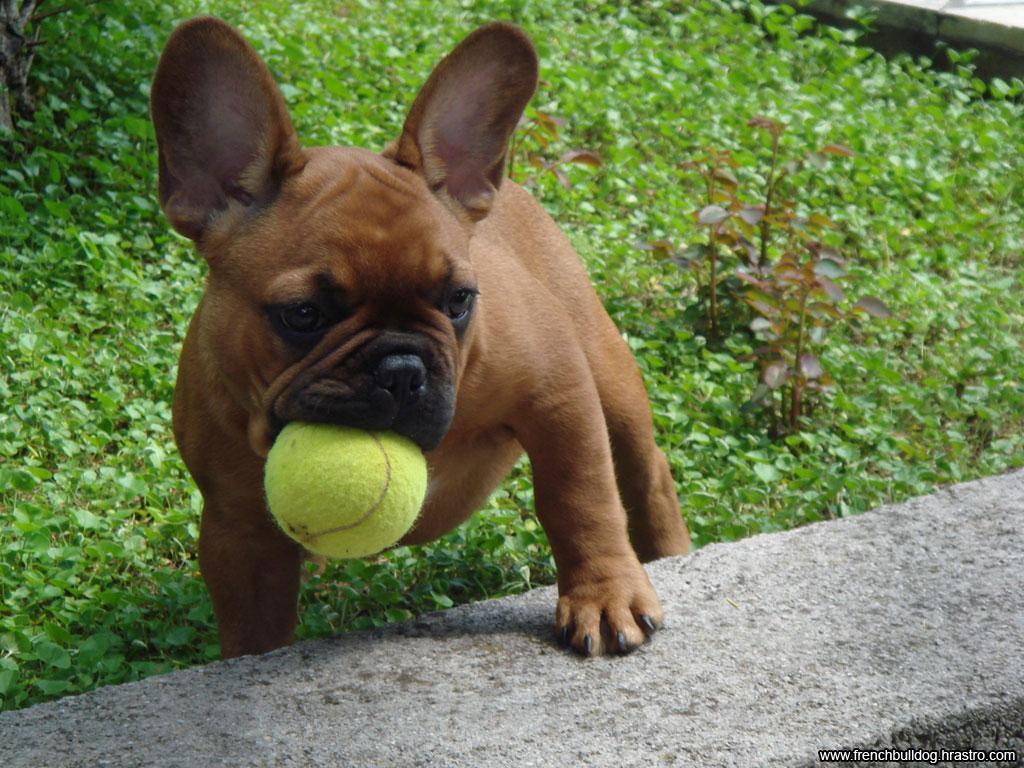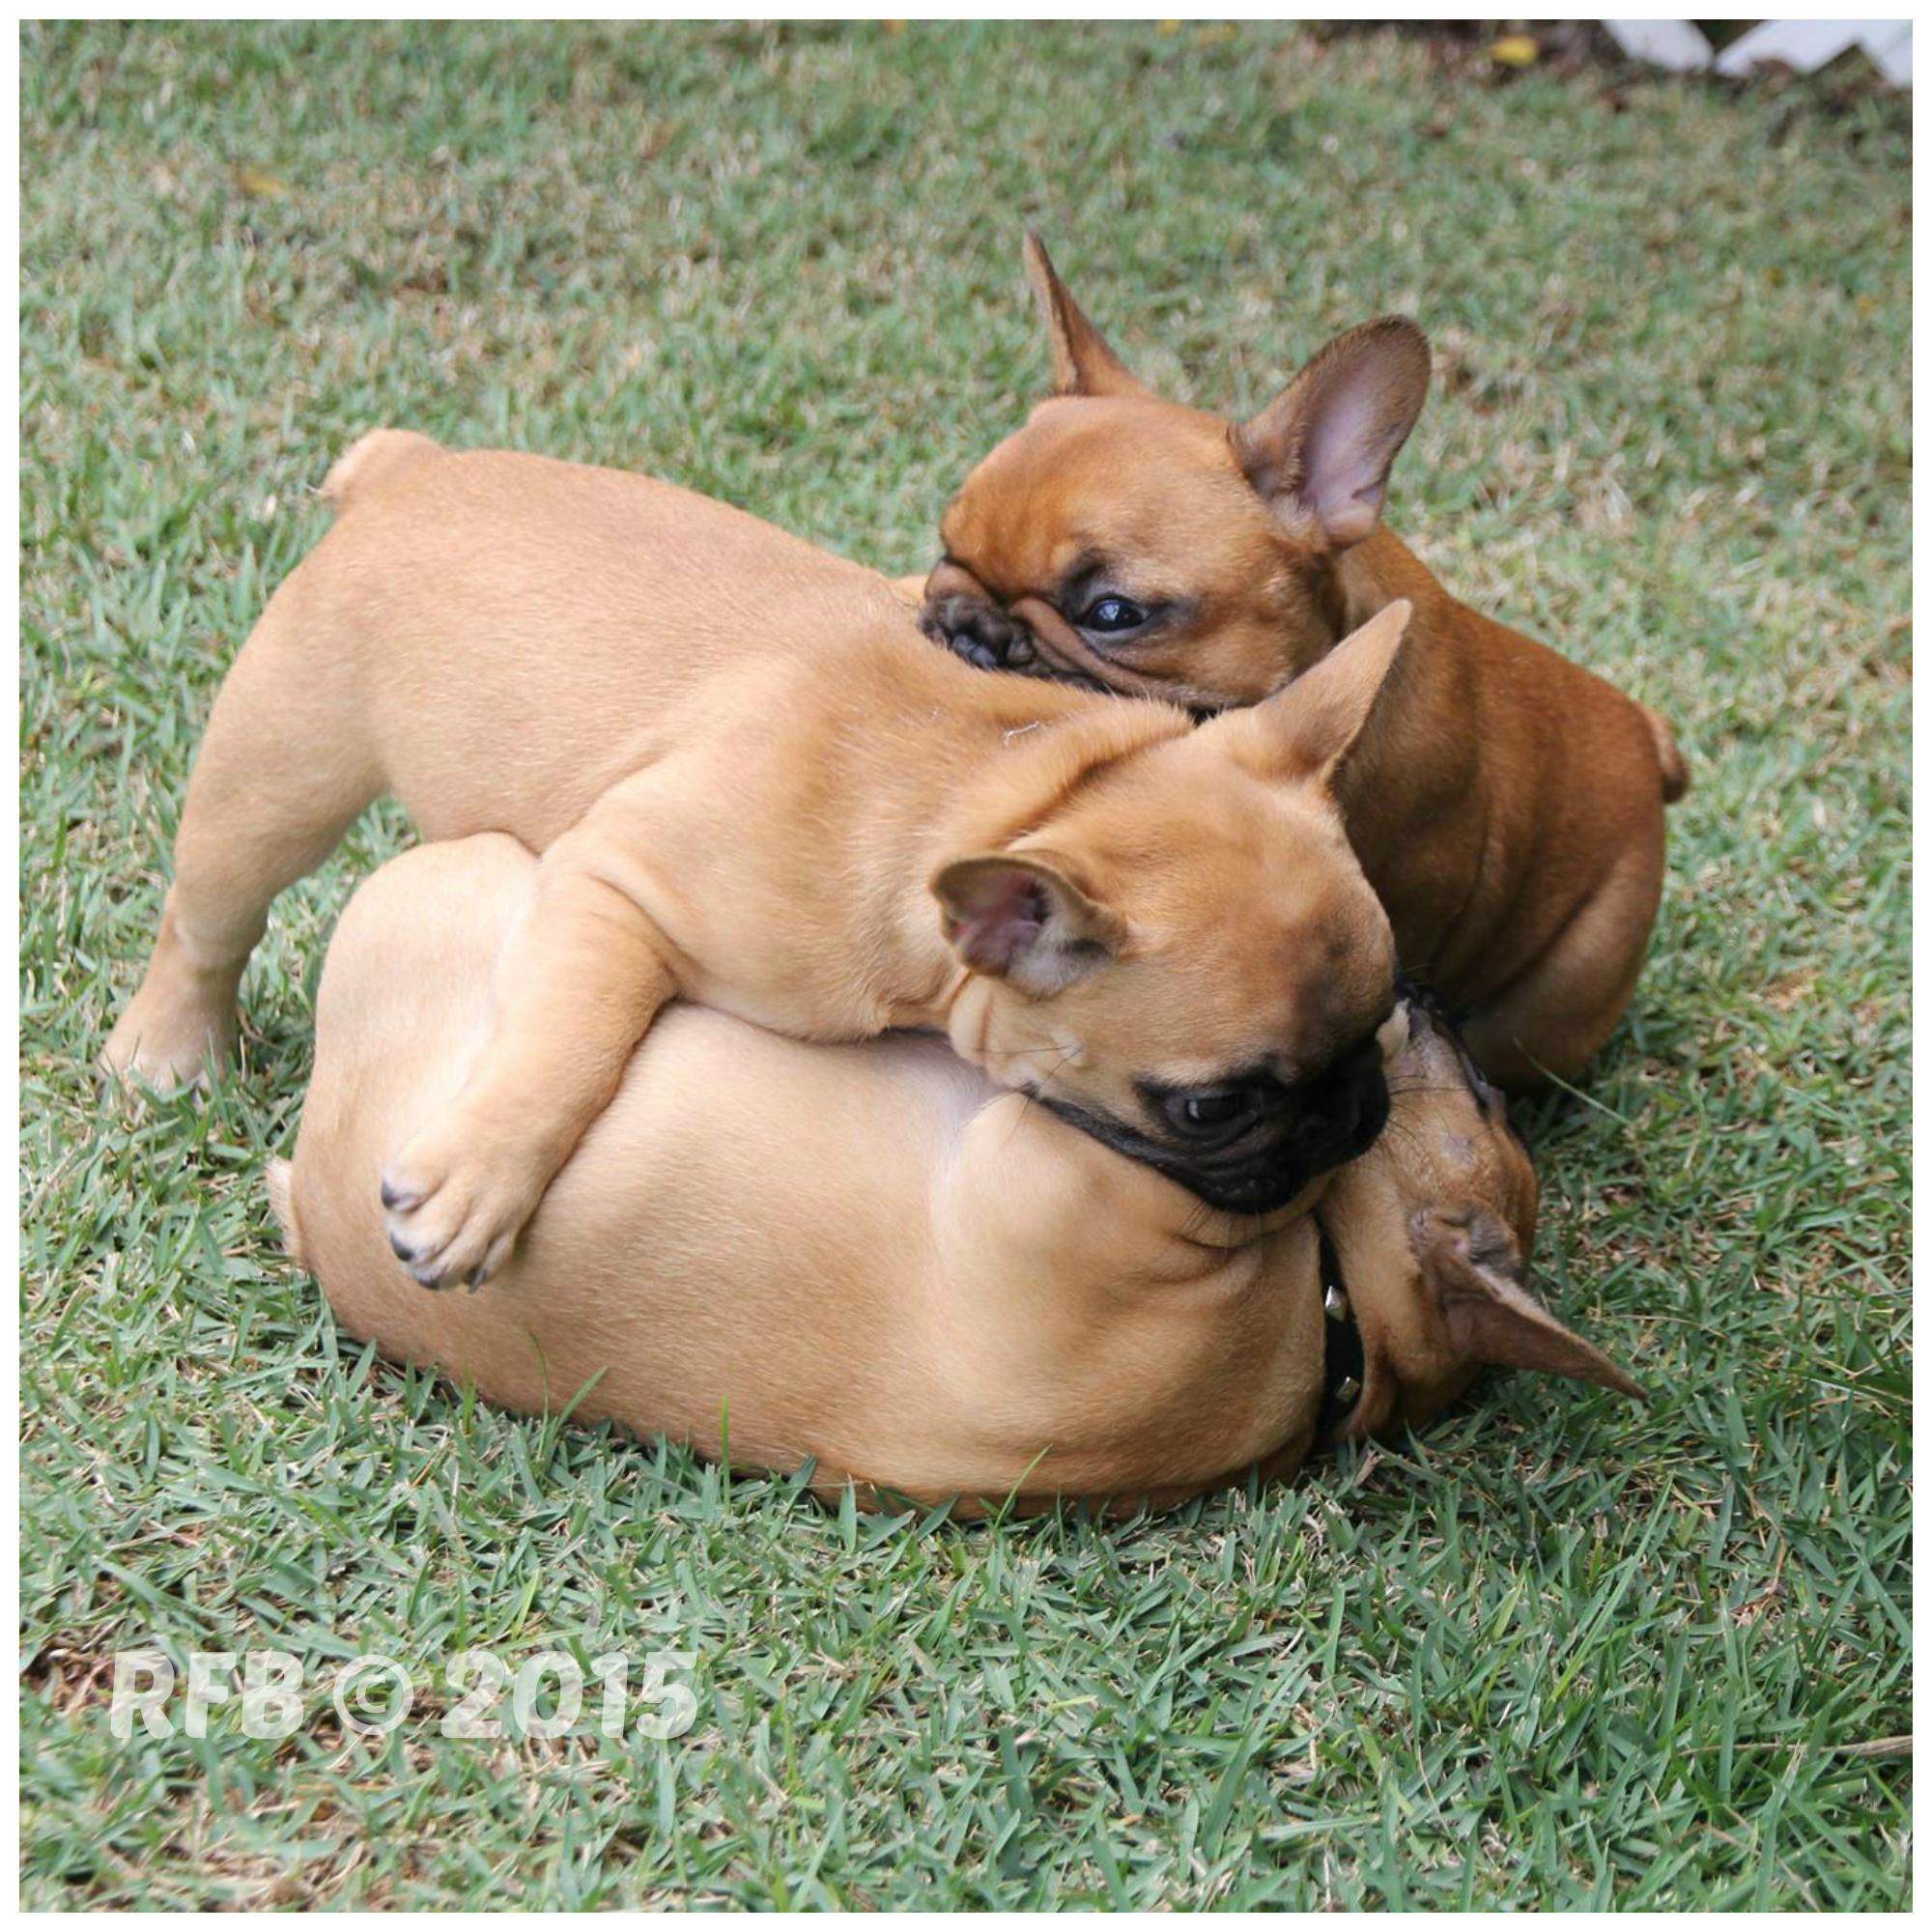The first image is the image on the left, the second image is the image on the right. Evaluate the accuracy of this statement regarding the images: "The right image contains at least two dogs.". Is it true? Answer yes or no. Yes. The first image is the image on the left, the second image is the image on the right. Considering the images on both sides, is "One image shows a tan big-eared dog standing with its body turned forward and holding a solid-colored toy in its mouth." valid? Answer yes or no. Yes. 